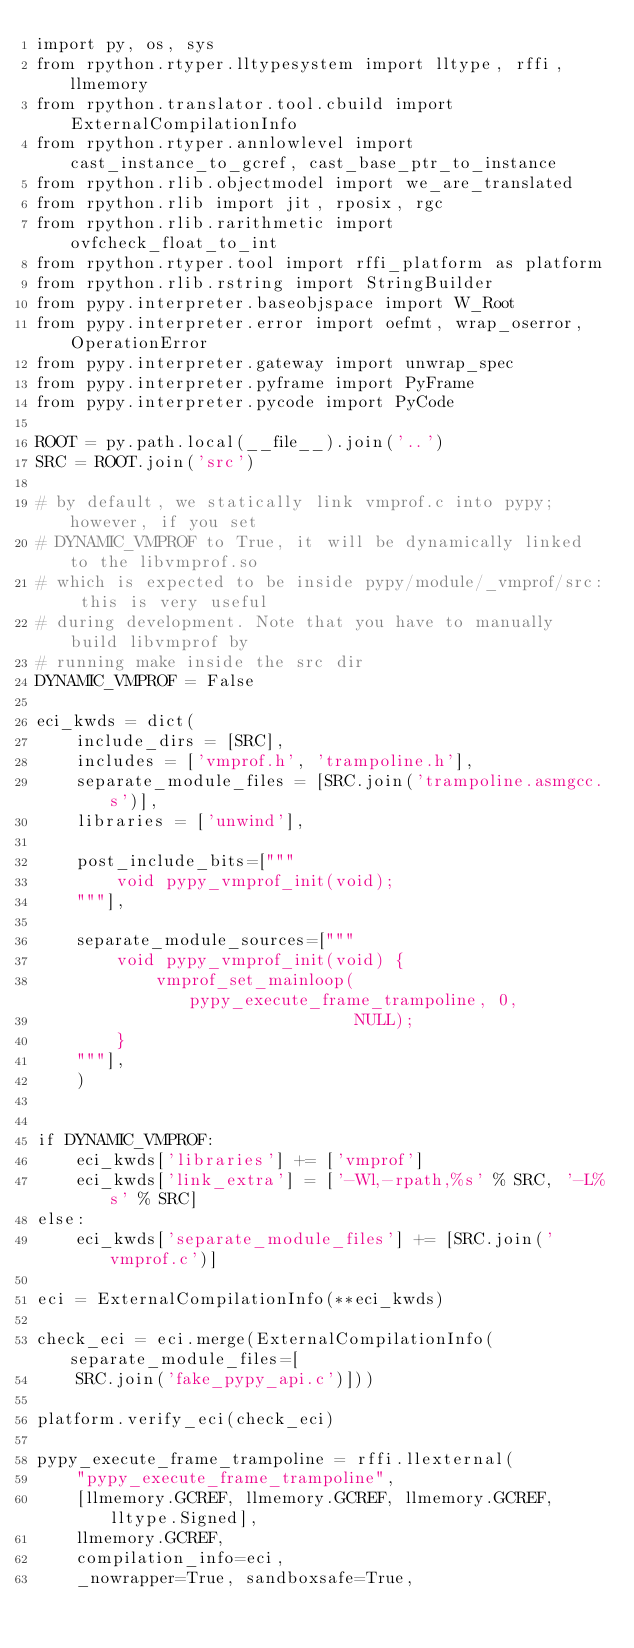Convert code to text. <code><loc_0><loc_0><loc_500><loc_500><_Python_>import py, os, sys
from rpython.rtyper.lltypesystem import lltype, rffi, llmemory
from rpython.translator.tool.cbuild import ExternalCompilationInfo
from rpython.rtyper.annlowlevel import cast_instance_to_gcref, cast_base_ptr_to_instance
from rpython.rlib.objectmodel import we_are_translated
from rpython.rlib import jit, rposix, rgc
from rpython.rlib.rarithmetic import ovfcheck_float_to_int
from rpython.rtyper.tool import rffi_platform as platform
from rpython.rlib.rstring import StringBuilder
from pypy.interpreter.baseobjspace import W_Root
from pypy.interpreter.error import oefmt, wrap_oserror, OperationError
from pypy.interpreter.gateway import unwrap_spec
from pypy.interpreter.pyframe import PyFrame
from pypy.interpreter.pycode import PyCode

ROOT = py.path.local(__file__).join('..')
SRC = ROOT.join('src')

# by default, we statically link vmprof.c into pypy; however, if you set
# DYNAMIC_VMPROF to True, it will be dynamically linked to the libvmprof.so
# which is expected to be inside pypy/module/_vmprof/src: this is very useful
# during development. Note that you have to manually build libvmprof by
# running make inside the src dir
DYNAMIC_VMPROF = False

eci_kwds = dict(
    include_dirs = [SRC],
    includes = ['vmprof.h', 'trampoline.h'],
    separate_module_files = [SRC.join('trampoline.asmgcc.s')],
    libraries = ['unwind'],
    
    post_include_bits=["""
        void pypy_vmprof_init(void);
    """],
    
    separate_module_sources=["""
        void pypy_vmprof_init(void) {
            vmprof_set_mainloop(pypy_execute_frame_trampoline, 0,
                                NULL);
        }
    """],
    )


if DYNAMIC_VMPROF:
    eci_kwds['libraries'] += ['vmprof']
    eci_kwds['link_extra'] = ['-Wl,-rpath,%s' % SRC, '-L%s' % SRC]
else:
    eci_kwds['separate_module_files'] += [SRC.join('vmprof.c')]

eci = ExternalCompilationInfo(**eci_kwds)

check_eci = eci.merge(ExternalCompilationInfo(separate_module_files=[
    SRC.join('fake_pypy_api.c')]))

platform.verify_eci(check_eci)

pypy_execute_frame_trampoline = rffi.llexternal(
    "pypy_execute_frame_trampoline",
    [llmemory.GCREF, llmemory.GCREF, llmemory.GCREF, lltype.Signed],
    llmemory.GCREF,
    compilation_info=eci,
    _nowrapper=True, sandboxsafe=True,</code> 